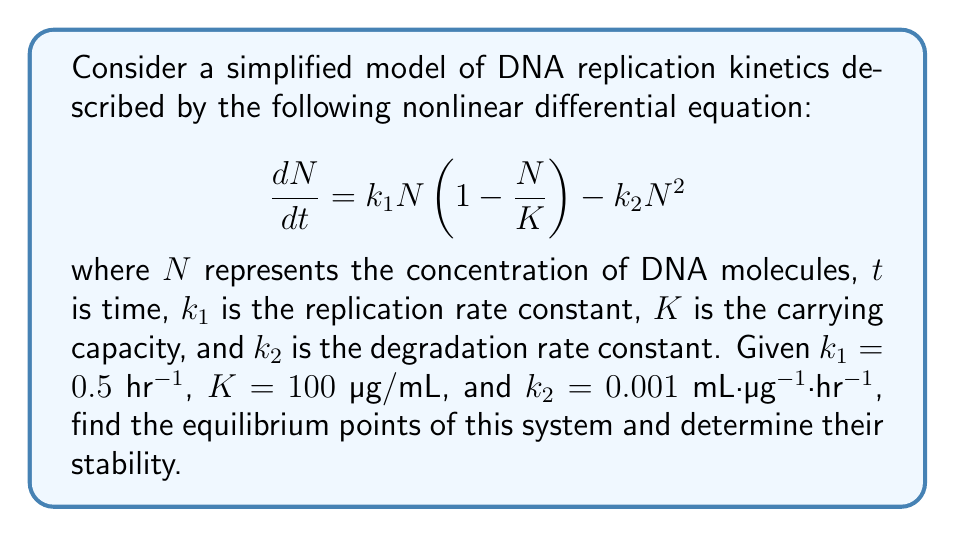Can you answer this question? To solve this problem, we'll follow these steps:

1) Find the equilibrium points:
   Equilibrium points occur when $\frac{dN}{dt} = 0$. So, we set the right-hand side of the equation to zero:

   $$k_1N(1-\frac{N}{K}) - k_2N^2 = 0$$

2) Factor out N:
   $$N(k_1(1-\frac{N}{K}) - k_2N) = 0$$

3) Solve the equation:
   We have two cases:
   a) $N = 0$ (trivial solution)
   b) $k_1(1-\frac{N}{K}) - k_2N = 0$

4) Solve case b:
   $$k_1 - \frac{k_1N}{K} - k_2N = 0$$
   $$k_1 = N(\frac{k_1}{K} + k_2)$$
   $$N = \frac{k_1}{\frac{k_1}{K} + k_2}$$

5) Substitute the given values:
   $$N = \frac{0.5}{\frac{0.5}{100} + 0.001} = 83.33 \text{ µg/mL}$$

6) Determine stability:
   To determine stability, we need to find $\frac{d}{dN}(\frac{dN}{dt})$ at each equilibrium point:

   $$\frac{d}{dN}(\frac{dN}{dt}) = k_1(1-\frac{2N}{K}) - 2k_2N$$

   a) At $N = 0$:
      $$\frac{d}{dN}(\frac{dN}{dt}) = k_1 = 0.5 > 0$$
      This is unstable.

   b) At $N = 83.33$:
      $$\frac{d}{dN}(\frac{dN}{dt}) = 0.5(1-\frac{2(83.33)}{100}) - 2(0.001)(83.33) = -0.333 < 0$$
      This is stable.

Therefore, we have two equilibrium points: 0 (unstable) and 83.33 µg/mL (stable).
Answer: Equilibrium points: 0 (unstable) and 83.33 µg/mL (stable) 